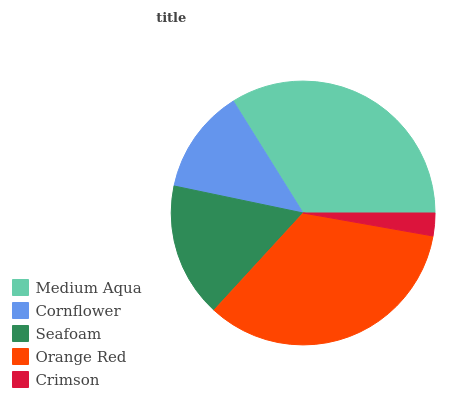Is Crimson the minimum?
Answer yes or no. Yes. Is Orange Red the maximum?
Answer yes or no. Yes. Is Cornflower the minimum?
Answer yes or no. No. Is Cornflower the maximum?
Answer yes or no. No. Is Medium Aqua greater than Cornflower?
Answer yes or no. Yes. Is Cornflower less than Medium Aqua?
Answer yes or no. Yes. Is Cornflower greater than Medium Aqua?
Answer yes or no. No. Is Medium Aqua less than Cornflower?
Answer yes or no. No. Is Seafoam the high median?
Answer yes or no. Yes. Is Seafoam the low median?
Answer yes or no. Yes. Is Orange Red the high median?
Answer yes or no. No. Is Orange Red the low median?
Answer yes or no. No. 